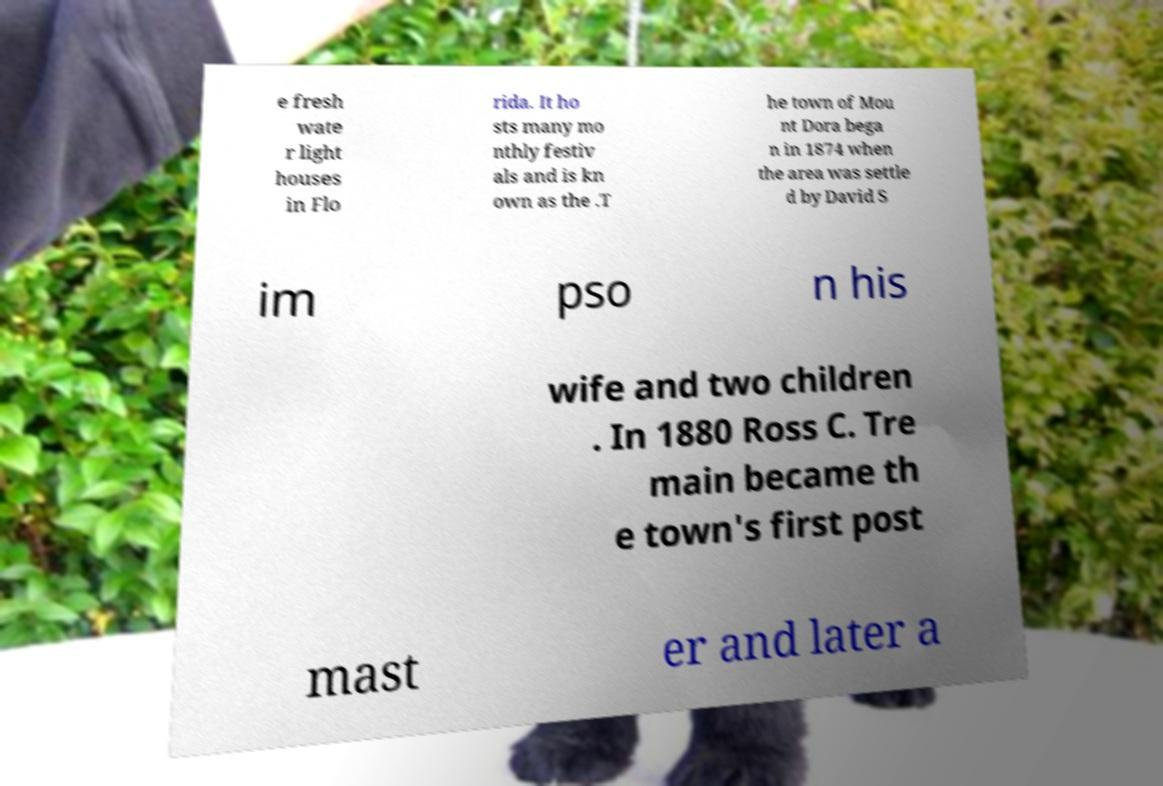For documentation purposes, I need the text within this image transcribed. Could you provide that? e fresh wate r light houses in Flo rida. It ho sts many mo nthly festiv als and is kn own as the .T he town of Mou nt Dora bega n in 1874 when the area was settle d by David S im pso n his wife and two children . In 1880 Ross C. Tre main became th e town's first post mast er and later a 